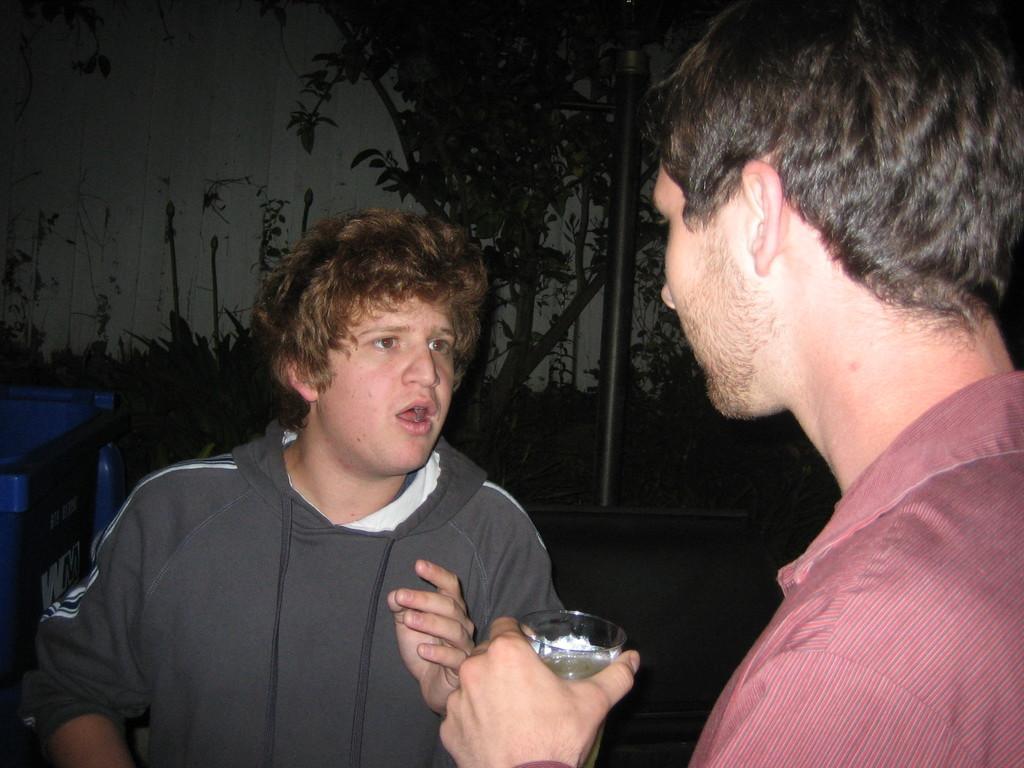Could you give a brief overview of what you see in this image? In this picture there are two men. One is holding a glass in his hand. There is a bin. There is a plant and a pole the background. 